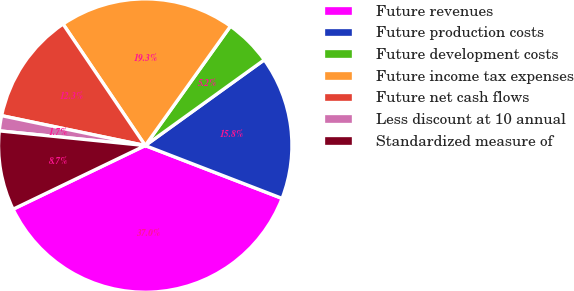Convert chart. <chart><loc_0><loc_0><loc_500><loc_500><pie_chart><fcel>Future revenues<fcel>Future production costs<fcel>Future development costs<fcel>Future income tax expenses<fcel>Future net cash flows<fcel>Less discount at 10 annual<fcel>Standardized measure of<nl><fcel>36.99%<fcel>15.8%<fcel>5.2%<fcel>19.33%<fcel>12.27%<fcel>1.67%<fcel>8.74%<nl></chart> 